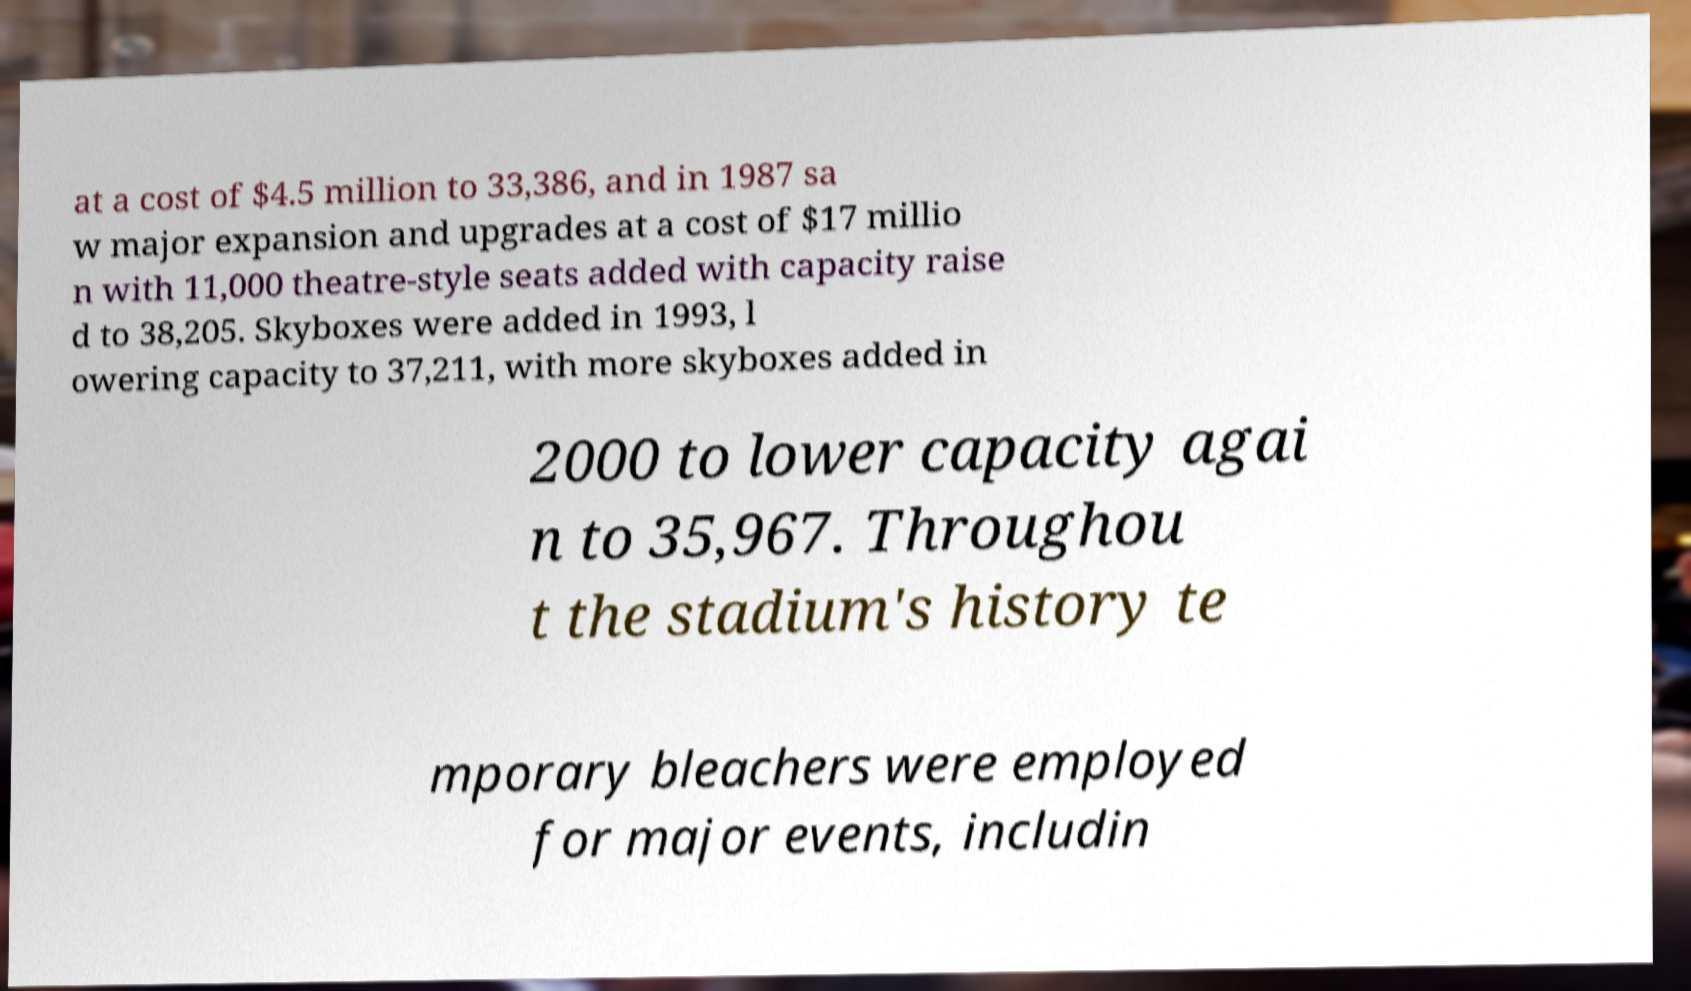Can you read and provide the text displayed in the image?This photo seems to have some interesting text. Can you extract and type it out for me? at a cost of $4.5 million to 33,386, and in 1987 sa w major expansion and upgrades at a cost of $17 millio n with 11,000 theatre-style seats added with capacity raise d to 38,205. Skyboxes were added in 1993, l owering capacity to 37,211, with more skyboxes added in 2000 to lower capacity agai n to 35,967. Throughou t the stadium's history te mporary bleachers were employed for major events, includin 